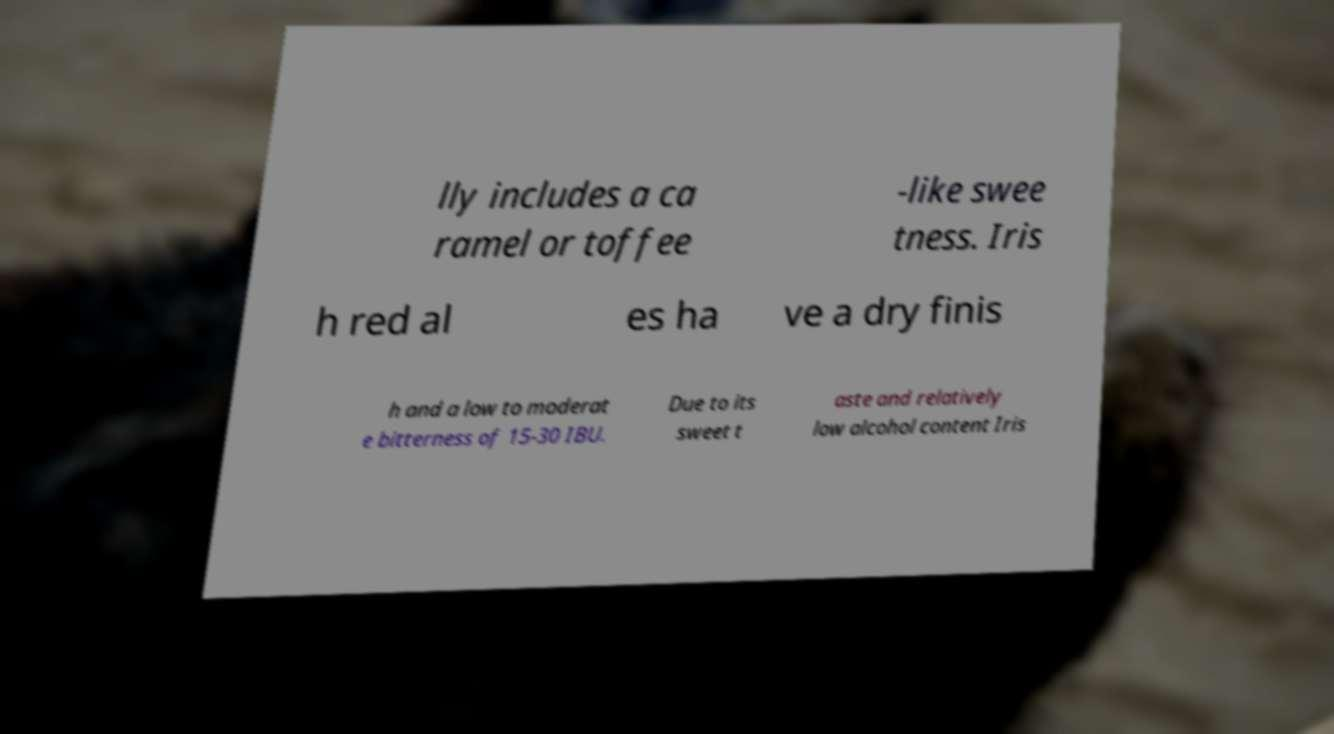Can you read and provide the text displayed in the image?This photo seems to have some interesting text. Can you extract and type it out for me? lly includes a ca ramel or toffee -like swee tness. Iris h red al es ha ve a dry finis h and a low to moderat e bitterness of 15-30 IBU. Due to its sweet t aste and relatively low alcohol content Iris 